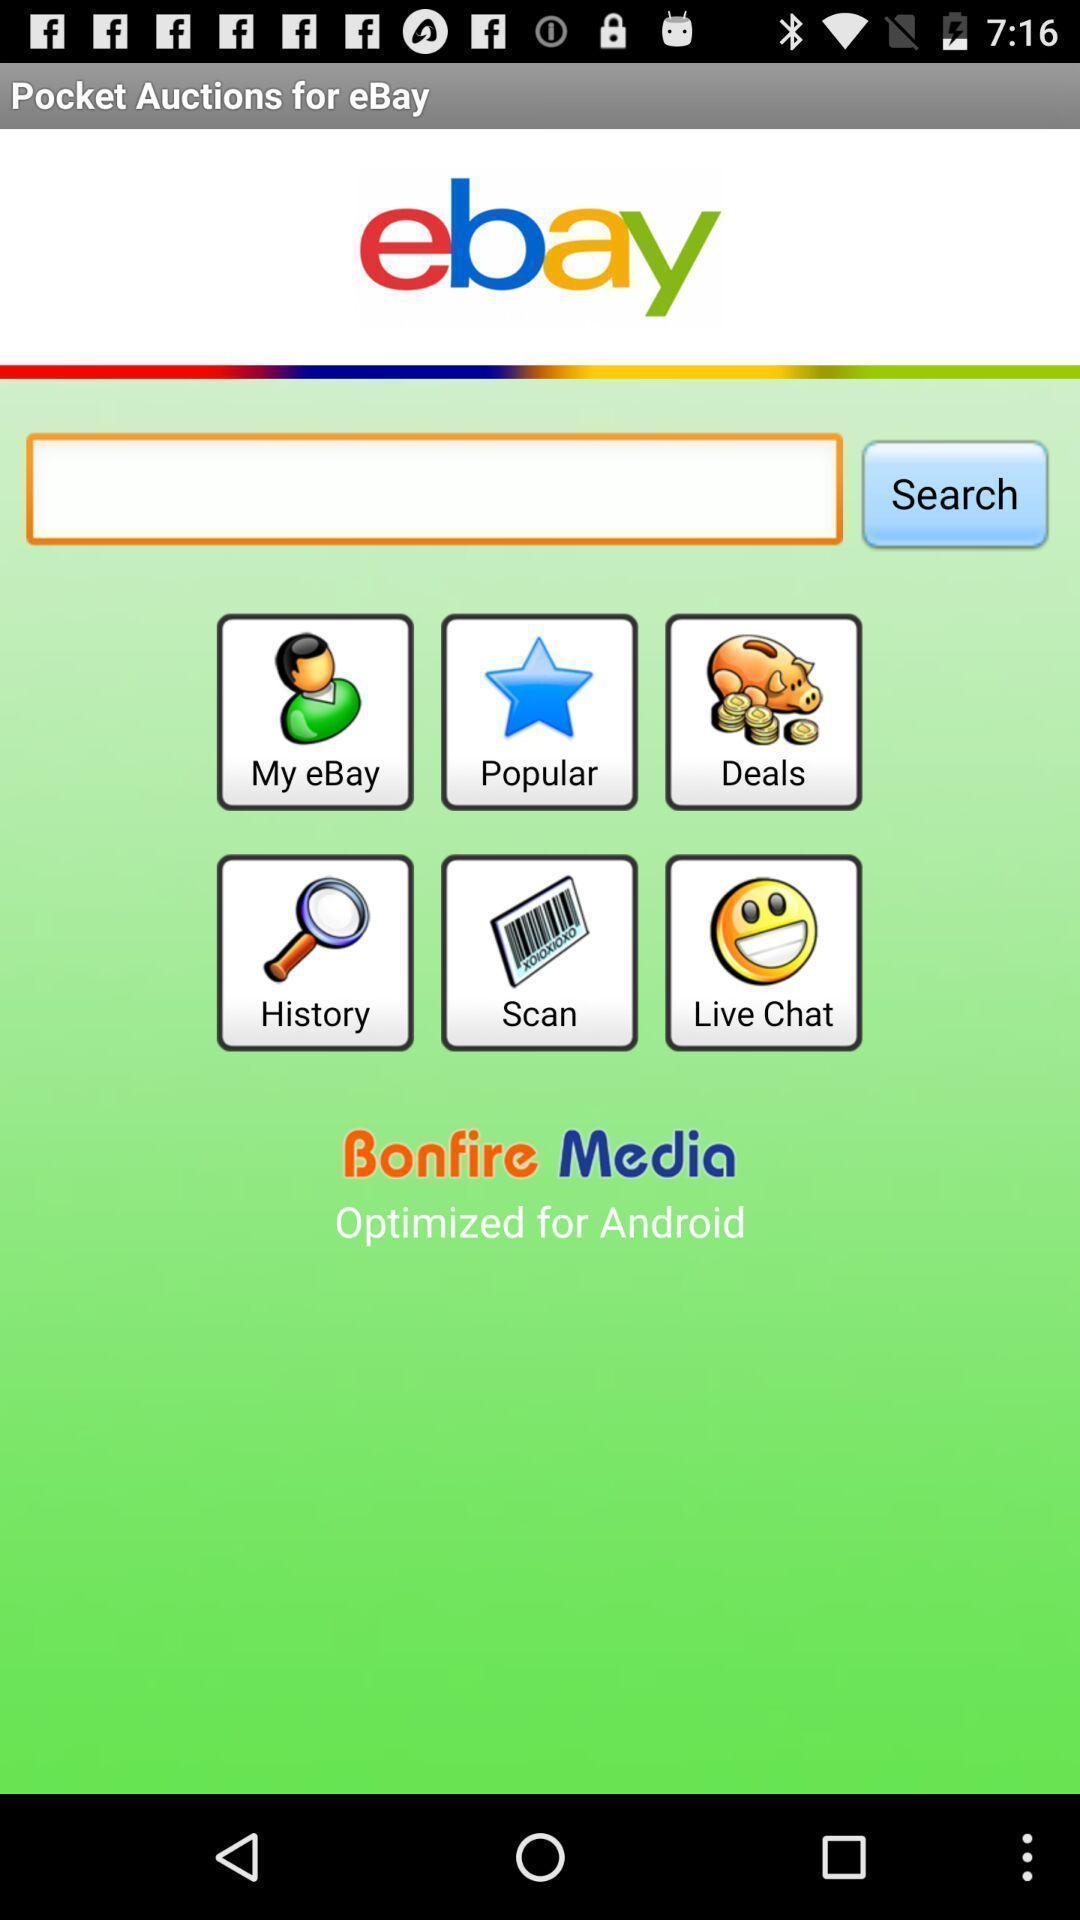Tell me what you see in this picture. Page showing multiple categories on shoppping app. 